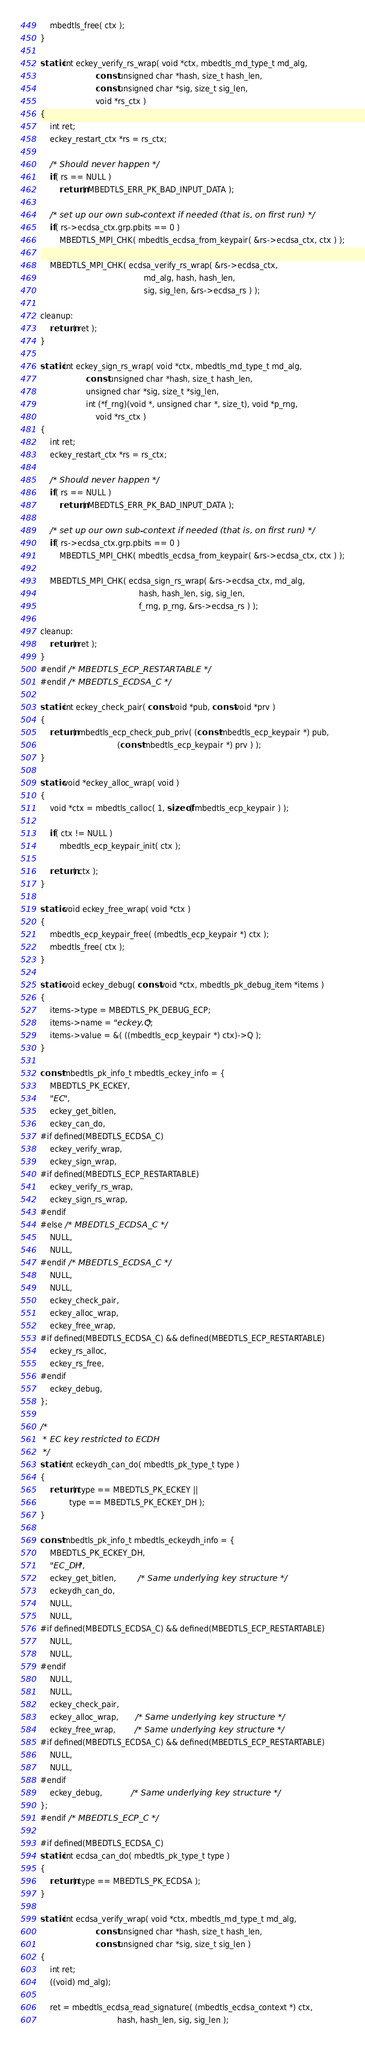<code> <loc_0><loc_0><loc_500><loc_500><_C_>    mbedtls_free( ctx );
}

static int eckey_verify_rs_wrap( void *ctx, mbedtls_md_type_t md_alg,
                       const unsigned char *hash, size_t hash_len,
                       const unsigned char *sig, size_t sig_len,
                       void *rs_ctx )
{
    int ret;
    eckey_restart_ctx *rs = rs_ctx;

    /* Should never happen */
    if( rs == NULL )
        return( MBEDTLS_ERR_PK_BAD_INPUT_DATA );

    /* set up our own sub-context if needed (that is, on first run) */
    if( rs->ecdsa_ctx.grp.pbits == 0 )
        MBEDTLS_MPI_CHK( mbedtls_ecdsa_from_keypair( &rs->ecdsa_ctx, ctx ) );

    MBEDTLS_MPI_CHK( ecdsa_verify_rs_wrap( &rs->ecdsa_ctx,
                                           md_alg, hash, hash_len,
                                           sig, sig_len, &rs->ecdsa_rs ) );

cleanup:
    return( ret );
}

static int eckey_sign_rs_wrap( void *ctx, mbedtls_md_type_t md_alg,
                   const unsigned char *hash, size_t hash_len,
                   unsigned char *sig, size_t *sig_len,
                   int (*f_rng)(void *, unsigned char *, size_t), void *p_rng,
                       void *rs_ctx )
{
    int ret;
    eckey_restart_ctx *rs = rs_ctx;

    /* Should never happen */
    if( rs == NULL )
        return( MBEDTLS_ERR_PK_BAD_INPUT_DATA );

    /* set up our own sub-context if needed (that is, on first run) */
    if( rs->ecdsa_ctx.grp.pbits == 0 )
        MBEDTLS_MPI_CHK( mbedtls_ecdsa_from_keypair( &rs->ecdsa_ctx, ctx ) );

    MBEDTLS_MPI_CHK( ecdsa_sign_rs_wrap( &rs->ecdsa_ctx, md_alg,
                                         hash, hash_len, sig, sig_len,
                                         f_rng, p_rng, &rs->ecdsa_rs ) );

cleanup:
    return( ret );
}
#endif /* MBEDTLS_ECP_RESTARTABLE */
#endif /* MBEDTLS_ECDSA_C */

static int eckey_check_pair( const void *pub, const void *prv )
{
    return( mbedtls_ecp_check_pub_priv( (const mbedtls_ecp_keypair *) pub,
                                (const mbedtls_ecp_keypair *) prv ) );
}

static void *eckey_alloc_wrap( void )
{
    void *ctx = mbedtls_calloc( 1, sizeof( mbedtls_ecp_keypair ) );

    if( ctx != NULL )
        mbedtls_ecp_keypair_init( ctx );

    return( ctx );
}

static void eckey_free_wrap( void *ctx )
{
    mbedtls_ecp_keypair_free( (mbedtls_ecp_keypair *) ctx );
    mbedtls_free( ctx );
}

static void eckey_debug( const void *ctx, mbedtls_pk_debug_item *items )
{
    items->type = MBEDTLS_PK_DEBUG_ECP;
    items->name = "eckey.Q";
    items->value = &( ((mbedtls_ecp_keypair *) ctx)->Q );
}

const mbedtls_pk_info_t mbedtls_eckey_info = {
    MBEDTLS_PK_ECKEY,
    "EC",
    eckey_get_bitlen,
    eckey_can_do,
#if defined(MBEDTLS_ECDSA_C)
    eckey_verify_wrap,
    eckey_sign_wrap,
#if defined(MBEDTLS_ECP_RESTARTABLE)
    eckey_verify_rs_wrap,
    eckey_sign_rs_wrap,
#endif
#else /* MBEDTLS_ECDSA_C */
    NULL,
    NULL,
#endif /* MBEDTLS_ECDSA_C */
    NULL,
    NULL,
    eckey_check_pair,
    eckey_alloc_wrap,
    eckey_free_wrap,
#if defined(MBEDTLS_ECDSA_C) && defined(MBEDTLS_ECP_RESTARTABLE)
    eckey_rs_alloc,
    eckey_rs_free,
#endif
    eckey_debug,
};

/*
 * EC key restricted to ECDH
 */
static int eckeydh_can_do( mbedtls_pk_type_t type )
{
    return( type == MBEDTLS_PK_ECKEY ||
            type == MBEDTLS_PK_ECKEY_DH );
}

const mbedtls_pk_info_t mbedtls_eckeydh_info = {
    MBEDTLS_PK_ECKEY_DH,
    "EC_DH",
    eckey_get_bitlen,         /* Same underlying key structure */
    eckeydh_can_do,
    NULL,
    NULL,
#if defined(MBEDTLS_ECDSA_C) && defined(MBEDTLS_ECP_RESTARTABLE)
    NULL,
    NULL,
#endif
    NULL,
    NULL,
    eckey_check_pair,
    eckey_alloc_wrap,       /* Same underlying key structure */
    eckey_free_wrap,        /* Same underlying key structure */
#if defined(MBEDTLS_ECDSA_C) && defined(MBEDTLS_ECP_RESTARTABLE)
    NULL,
    NULL,
#endif
    eckey_debug,            /* Same underlying key structure */
};
#endif /* MBEDTLS_ECP_C */

#if defined(MBEDTLS_ECDSA_C)
static int ecdsa_can_do( mbedtls_pk_type_t type )
{
    return( type == MBEDTLS_PK_ECDSA );
}

static int ecdsa_verify_wrap( void *ctx, mbedtls_md_type_t md_alg,
                       const unsigned char *hash, size_t hash_len,
                       const unsigned char *sig, size_t sig_len )
{
    int ret;
    ((void) md_alg);

    ret = mbedtls_ecdsa_read_signature( (mbedtls_ecdsa_context *) ctx,
                                hash, hash_len, sig, sig_len );
</code> 